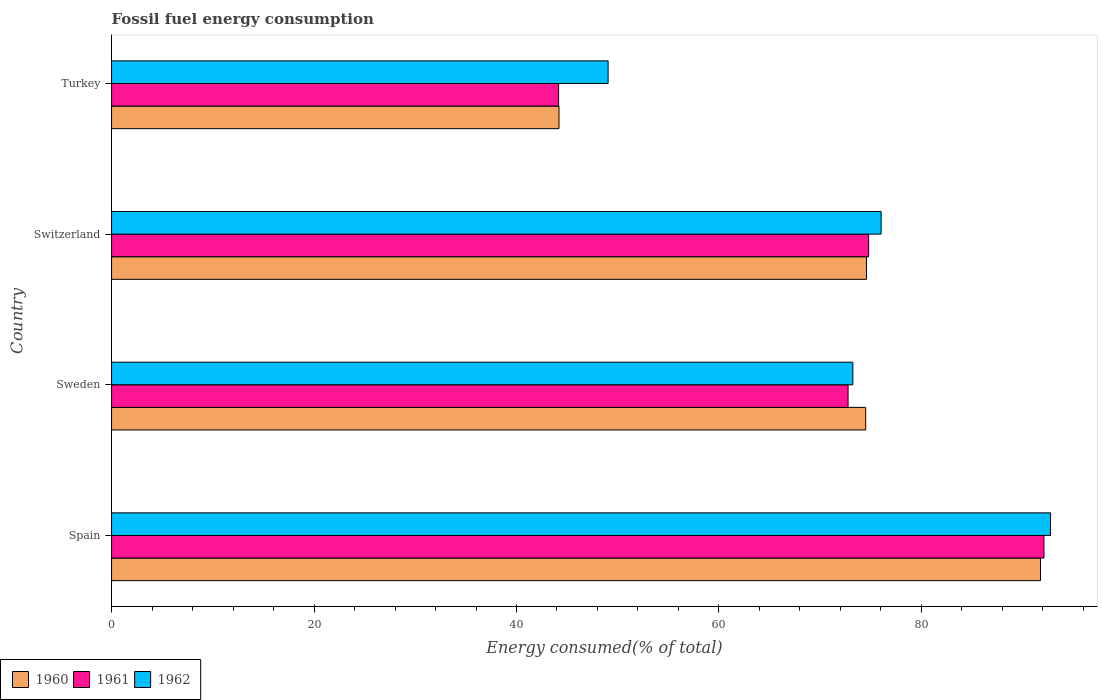How many groups of bars are there?
Offer a terse response. 4. Are the number of bars on each tick of the Y-axis equal?
Your answer should be compact. Yes. How many bars are there on the 4th tick from the bottom?
Provide a short and direct response. 3. What is the percentage of energy consumed in 1962 in Switzerland?
Make the answer very short. 76.02. Across all countries, what is the maximum percentage of energy consumed in 1962?
Provide a short and direct response. 92.75. Across all countries, what is the minimum percentage of energy consumed in 1962?
Your answer should be very brief. 49.05. In which country was the percentage of energy consumed in 1962 maximum?
Your answer should be very brief. Spain. In which country was the percentage of energy consumed in 1961 minimum?
Your response must be concise. Turkey. What is the total percentage of energy consumed in 1962 in the graph?
Keep it short and to the point. 291.05. What is the difference between the percentage of energy consumed in 1962 in Sweden and that in Switzerland?
Give a very brief answer. -2.79. What is the difference between the percentage of energy consumed in 1960 in Turkey and the percentage of energy consumed in 1962 in Switzerland?
Offer a terse response. -31.82. What is the average percentage of energy consumed in 1962 per country?
Offer a very short reply. 72.76. What is the difference between the percentage of energy consumed in 1961 and percentage of energy consumed in 1962 in Spain?
Your answer should be compact. -0.65. What is the ratio of the percentage of energy consumed in 1961 in Sweden to that in Switzerland?
Provide a succinct answer. 0.97. Is the difference between the percentage of energy consumed in 1961 in Spain and Sweden greater than the difference between the percentage of energy consumed in 1962 in Spain and Sweden?
Give a very brief answer. No. What is the difference between the highest and the second highest percentage of energy consumed in 1960?
Provide a short and direct response. 17.19. What is the difference between the highest and the lowest percentage of energy consumed in 1960?
Your response must be concise. 47.57. In how many countries, is the percentage of energy consumed in 1960 greater than the average percentage of energy consumed in 1960 taken over all countries?
Your answer should be compact. 3. Is the sum of the percentage of energy consumed in 1962 in Switzerland and Turkey greater than the maximum percentage of energy consumed in 1960 across all countries?
Provide a succinct answer. Yes. Is it the case that in every country, the sum of the percentage of energy consumed in 1961 and percentage of energy consumed in 1962 is greater than the percentage of energy consumed in 1960?
Ensure brevity in your answer.  Yes. How many bars are there?
Your answer should be very brief. 12. Are all the bars in the graph horizontal?
Your response must be concise. Yes. What is the difference between two consecutive major ticks on the X-axis?
Make the answer very short. 20. Are the values on the major ticks of X-axis written in scientific E-notation?
Your answer should be very brief. No. Does the graph contain any zero values?
Give a very brief answer. No. Where does the legend appear in the graph?
Your answer should be compact. Bottom left. How many legend labels are there?
Your response must be concise. 3. How are the legend labels stacked?
Provide a succinct answer. Horizontal. What is the title of the graph?
Ensure brevity in your answer.  Fossil fuel energy consumption. What is the label or title of the X-axis?
Provide a succinct answer. Energy consumed(% of total). What is the label or title of the Y-axis?
Your answer should be compact. Country. What is the Energy consumed(% of total) of 1960 in Spain?
Provide a short and direct response. 91.77. What is the Energy consumed(% of total) of 1961 in Spain?
Offer a terse response. 92.1. What is the Energy consumed(% of total) of 1962 in Spain?
Provide a short and direct response. 92.75. What is the Energy consumed(% of total) of 1960 in Sweden?
Provide a short and direct response. 74.49. What is the Energy consumed(% of total) in 1961 in Sweden?
Offer a very short reply. 72.75. What is the Energy consumed(% of total) of 1962 in Sweden?
Give a very brief answer. 73.23. What is the Energy consumed(% of total) in 1960 in Switzerland?
Make the answer very short. 74.57. What is the Energy consumed(% of total) of 1961 in Switzerland?
Provide a short and direct response. 74.78. What is the Energy consumed(% of total) in 1962 in Switzerland?
Give a very brief answer. 76.02. What is the Energy consumed(% of total) in 1960 in Turkey?
Your answer should be compact. 44.2. What is the Energy consumed(% of total) of 1961 in Turkey?
Offer a very short reply. 44.16. What is the Energy consumed(% of total) of 1962 in Turkey?
Offer a terse response. 49.05. Across all countries, what is the maximum Energy consumed(% of total) of 1960?
Your response must be concise. 91.77. Across all countries, what is the maximum Energy consumed(% of total) of 1961?
Give a very brief answer. 92.1. Across all countries, what is the maximum Energy consumed(% of total) of 1962?
Offer a very short reply. 92.75. Across all countries, what is the minimum Energy consumed(% of total) in 1960?
Your response must be concise. 44.2. Across all countries, what is the minimum Energy consumed(% of total) of 1961?
Provide a succinct answer. 44.16. Across all countries, what is the minimum Energy consumed(% of total) of 1962?
Your answer should be very brief. 49.05. What is the total Energy consumed(% of total) in 1960 in the graph?
Offer a very short reply. 285.03. What is the total Energy consumed(% of total) of 1961 in the graph?
Provide a short and direct response. 283.8. What is the total Energy consumed(% of total) in 1962 in the graph?
Ensure brevity in your answer.  291.05. What is the difference between the Energy consumed(% of total) in 1960 in Spain and that in Sweden?
Keep it short and to the point. 17.27. What is the difference between the Energy consumed(% of total) of 1961 in Spain and that in Sweden?
Keep it short and to the point. 19.35. What is the difference between the Energy consumed(% of total) of 1962 in Spain and that in Sweden?
Provide a succinct answer. 19.53. What is the difference between the Energy consumed(% of total) in 1960 in Spain and that in Switzerland?
Offer a terse response. 17.19. What is the difference between the Energy consumed(% of total) in 1961 in Spain and that in Switzerland?
Ensure brevity in your answer.  17.32. What is the difference between the Energy consumed(% of total) of 1962 in Spain and that in Switzerland?
Ensure brevity in your answer.  16.74. What is the difference between the Energy consumed(% of total) of 1960 in Spain and that in Turkey?
Ensure brevity in your answer.  47.57. What is the difference between the Energy consumed(% of total) in 1961 in Spain and that in Turkey?
Ensure brevity in your answer.  47.95. What is the difference between the Energy consumed(% of total) in 1962 in Spain and that in Turkey?
Provide a succinct answer. 43.7. What is the difference between the Energy consumed(% of total) in 1960 in Sweden and that in Switzerland?
Offer a terse response. -0.08. What is the difference between the Energy consumed(% of total) of 1961 in Sweden and that in Switzerland?
Offer a terse response. -2.03. What is the difference between the Energy consumed(% of total) of 1962 in Sweden and that in Switzerland?
Offer a terse response. -2.79. What is the difference between the Energy consumed(% of total) in 1960 in Sweden and that in Turkey?
Ensure brevity in your answer.  30.29. What is the difference between the Energy consumed(% of total) of 1961 in Sweden and that in Turkey?
Give a very brief answer. 28.59. What is the difference between the Energy consumed(% of total) in 1962 in Sweden and that in Turkey?
Provide a short and direct response. 24.18. What is the difference between the Energy consumed(% of total) of 1960 in Switzerland and that in Turkey?
Your answer should be very brief. 30.37. What is the difference between the Energy consumed(% of total) of 1961 in Switzerland and that in Turkey?
Keep it short and to the point. 30.62. What is the difference between the Energy consumed(% of total) of 1962 in Switzerland and that in Turkey?
Offer a very short reply. 26.97. What is the difference between the Energy consumed(% of total) of 1960 in Spain and the Energy consumed(% of total) of 1961 in Sweden?
Make the answer very short. 19.01. What is the difference between the Energy consumed(% of total) of 1960 in Spain and the Energy consumed(% of total) of 1962 in Sweden?
Offer a terse response. 18.54. What is the difference between the Energy consumed(% of total) of 1961 in Spain and the Energy consumed(% of total) of 1962 in Sweden?
Your answer should be very brief. 18.88. What is the difference between the Energy consumed(% of total) of 1960 in Spain and the Energy consumed(% of total) of 1961 in Switzerland?
Your answer should be compact. 16.98. What is the difference between the Energy consumed(% of total) of 1960 in Spain and the Energy consumed(% of total) of 1962 in Switzerland?
Keep it short and to the point. 15.75. What is the difference between the Energy consumed(% of total) of 1961 in Spain and the Energy consumed(% of total) of 1962 in Switzerland?
Offer a terse response. 16.09. What is the difference between the Energy consumed(% of total) of 1960 in Spain and the Energy consumed(% of total) of 1961 in Turkey?
Ensure brevity in your answer.  47.61. What is the difference between the Energy consumed(% of total) in 1960 in Spain and the Energy consumed(% of total) in 1962 in Turkey?
Provide a short and direct response. 42.72. What is the difference between the Energy consumed(% of total) in 1961 in Spain and the Energy consumed(% of total) in 1962 in Turkey?
Provide a short and direct response. 43.05. What is the difference between the Energy consumed(% of total) in 1960 in Sweden and the Energy consumed(% of total) in 1961 in Switzerland?
Offer a very short reply. -0.29. What is the difference between the Energy consumed(% of total) of 1960 in Sweden and the Energy consumed(% of total) of 1962 in Switzerland?
Your answer should be very brief. -1.52. What is the difference between the Energy consumed(% of total) in 1961 in Sweden and the Energy consumed(% of total) in 1962 in Switzerland?
Make the answer very short. -3.26. What is the difference between the Energy consumed(% of total) of 1960 in Sweden and the Energy consumed(% of total) of 1961 in Turkey?
Provide a short and direct response. 30.33. What is the difference between the Energy consumed(% of total) of 1960 in Sweden and the Energy consumed(% of total) of 1962 in Turkey?
Give a very brief answer. 25.44. What is the difference between the Energy consumed(% of total) of 1961 in Sweden and the Energy consumed(% of total) of 1962 in Turkey?
Make the answer very short. 23.7. What is the difference between the Energy consumed(% of total) in 1960 in Switzerland and the Energy consumed(% of total) in 1961 in Turkey?
Your answer should be compact. 30.41. What is the difference between the Energy consumed(% of total) of 1960 in Switzerland and the Energy consumed(% of total) of 1962 in Turkey?
Your response must be concise. 25.52. What is the difference between the Energy consumed(% of total) of 1961 in Switzerland and the Energy consumed(% of total) of 1962 in Turkey?
Make the answer very short. 25.73. What is the average Energy consumed(% of total) in 1960 per country?
Provide a short and direct response. 71.26. What is the average Energy consumed(% of total) of 1961 per country?
Keep it short and to the point. 70.95. What is the average Energy consumed(% of total) of 1962 per country?
Provide a short and direct response. 72.76. What is the difference between the Energy consumed(% of total) of 1960 and Energy consumed(% of total) of 1961 in Spain?
Provide a succinct answer. -0.34. What is the difference between the Energy consumed(% of total) in 1960 and Energy consumed(% of total) in 1962 in Spain?
Provide a succinct answer. -0.99. What is the difference between the Energy consumed(% of total) of 1961 and Energy consumed(% of total) of 1962 in Spain?
Keep it short and to the point. -0.65. What is the difference between the Energy consumed(% of total) of 1960 and Energy consumed(% of total) of 1961 in Sweden?
Your answer should be very brief. 1.74. What is the difference between the Energy consumed(% of total) of 1960 and Energy consumed(% of total) of 1962 in Sweden?
Give a very brief answer. 1.27. What is the difference between the Energy consumed(% of total) of 1961 and Energy consumed(% of total) of 1962 in Sweden?
Make the answer very short. -0.47. What is the difference between the Energy consumed(% of total) in 1960 and Energy consumed(% of total) in 1961 in Switzerland?
Your response must be concise. -0.21. What is the difference between the Energy consumed(% of total) of 1960 and Energy consumed(% of total) of 1962 in Switzerland?
Keep it short and to the point. -1.45. What is the difference between the Energy consumed(% of total) of 1961 and Energy consumed(% of total) of 1962 in Switzerland?
Ensure brevity in your answer.  -1.23. What is the difference between the Energy consumed(% of total) in 1960 and Energy consumed(% of total) in 1962 in Turkey?
Provide a succinct answer. -4.85. What is the difference between the Energy consumed(% of total) of 1961 and Energy consumed(% of total) of 1962 in Turkey?
Keep it short and to the point. -4.89. What is the ratio of the Energy consumed(% of total) of 1960 in Spain to that in Sweden?
Your response must be concise. 1.23. What is the ratio of the Energy consumed(% of total) in 1961 in Spain to that in Sweden?
Offer a very short reply. 1.27. What is the ratio of the Energy consumed(% of total) in 1962 in Spain to that in Sweden?
Your answer should be compact. 1.27. What is the ratio of the Energy consumed(% of total) in 1960 in Spain to that in Switzerland?
Keep it short and to the point. 1.23. What is the ratio of the Energy consumed(% of total) of 1961 in Spain to that in Switzerland?
Offer a terse response. 1.23. What is the ratio of the Energy consumed(% of total) in 1962 in Spain to that in Switzerland?
Your response must be concise. 1.22. What is the ratio of the Energy consumed(% of total) of 1960 in Spain to that in Turkey?
Your response must be concise. 2.08. What is the ratio of the Energy consumed(% of total) of 1961 in Spain to that in Turkey?
Your answer should be compact. 2.09. What is the ratio of the Energy consumed(% of total) of 1962 in Spain to that in Turkey?
Provide a short and direct response. 1.89. What is the ratio of the Energy consumed(% of total) in 1961 in Sweden to that in Switzerland?
Offer a terse response. 0.97. What is the ratio of the Energy consumed(% of total) of 1962 in Sweden to that in Switzerland?
Your response must be concise. 0.96. What is the ratio of the Energy consumed(% of total) in 1960 in Sweden to that in Turkey?
Your response must be concise. 1.69. What is the ratio of the Energy consumed(% of total) in 1961 in Sweden to that in Turkey?
Provide a short and direct response. 1.65. What is the ratio of the Energy consumed(% of total) of 1962 in Sweden to that in Turkey?
Keep it short and to the point. 1.49. What is the ratio of the Energy consumed(% of total) in 1960 in Switzerland to that in Turkey?
Provide a succinct answer. 1.69. What is the ratio of the Energy consumed(% of total) of 1961 in Switzerland to that in Turkey?
Make the answer very short. 1.69. What is the ratio of the Energy consumed(% of total) in 1962 in Switzerland to that in Turkey?
Ensure brevity in your answer.  1.55. What is the difference between the highest and the second highest Energy consumed(% of total) of 1960?
Provide a succinct answer. 17.19. What is the difference between the highest and the second highest Energy consumed(% of total) in 1961?
Make the answer very short. 17.32. What is the difference between the highest and the second highest Energy consumed(% of total) in 1962?
Provide a short and direct response. 16.74. What is the difference between the highest and the lowest Energy consumed(% of total) of 1960?
Provide a succinct answer. 47.57. What is the difference between the highest and the lowest Energy consumed(% of total) in 1961?
Keep it short and to the point. 47.95. What is the difference between the highest and the lowest Energy consumed(% of total) of 1962?
Make the answer very short. 43.7. 